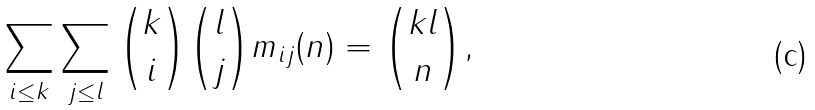Convert formula to latex. <formula><loc_0><loc_0><loc_500><loc_500>\sum _ { i \leq k } \sum _ { j \leq l } { k \choose i } { l \choose j } m _ { i j } ( n ) = { k l \choose n } ,</formula> 